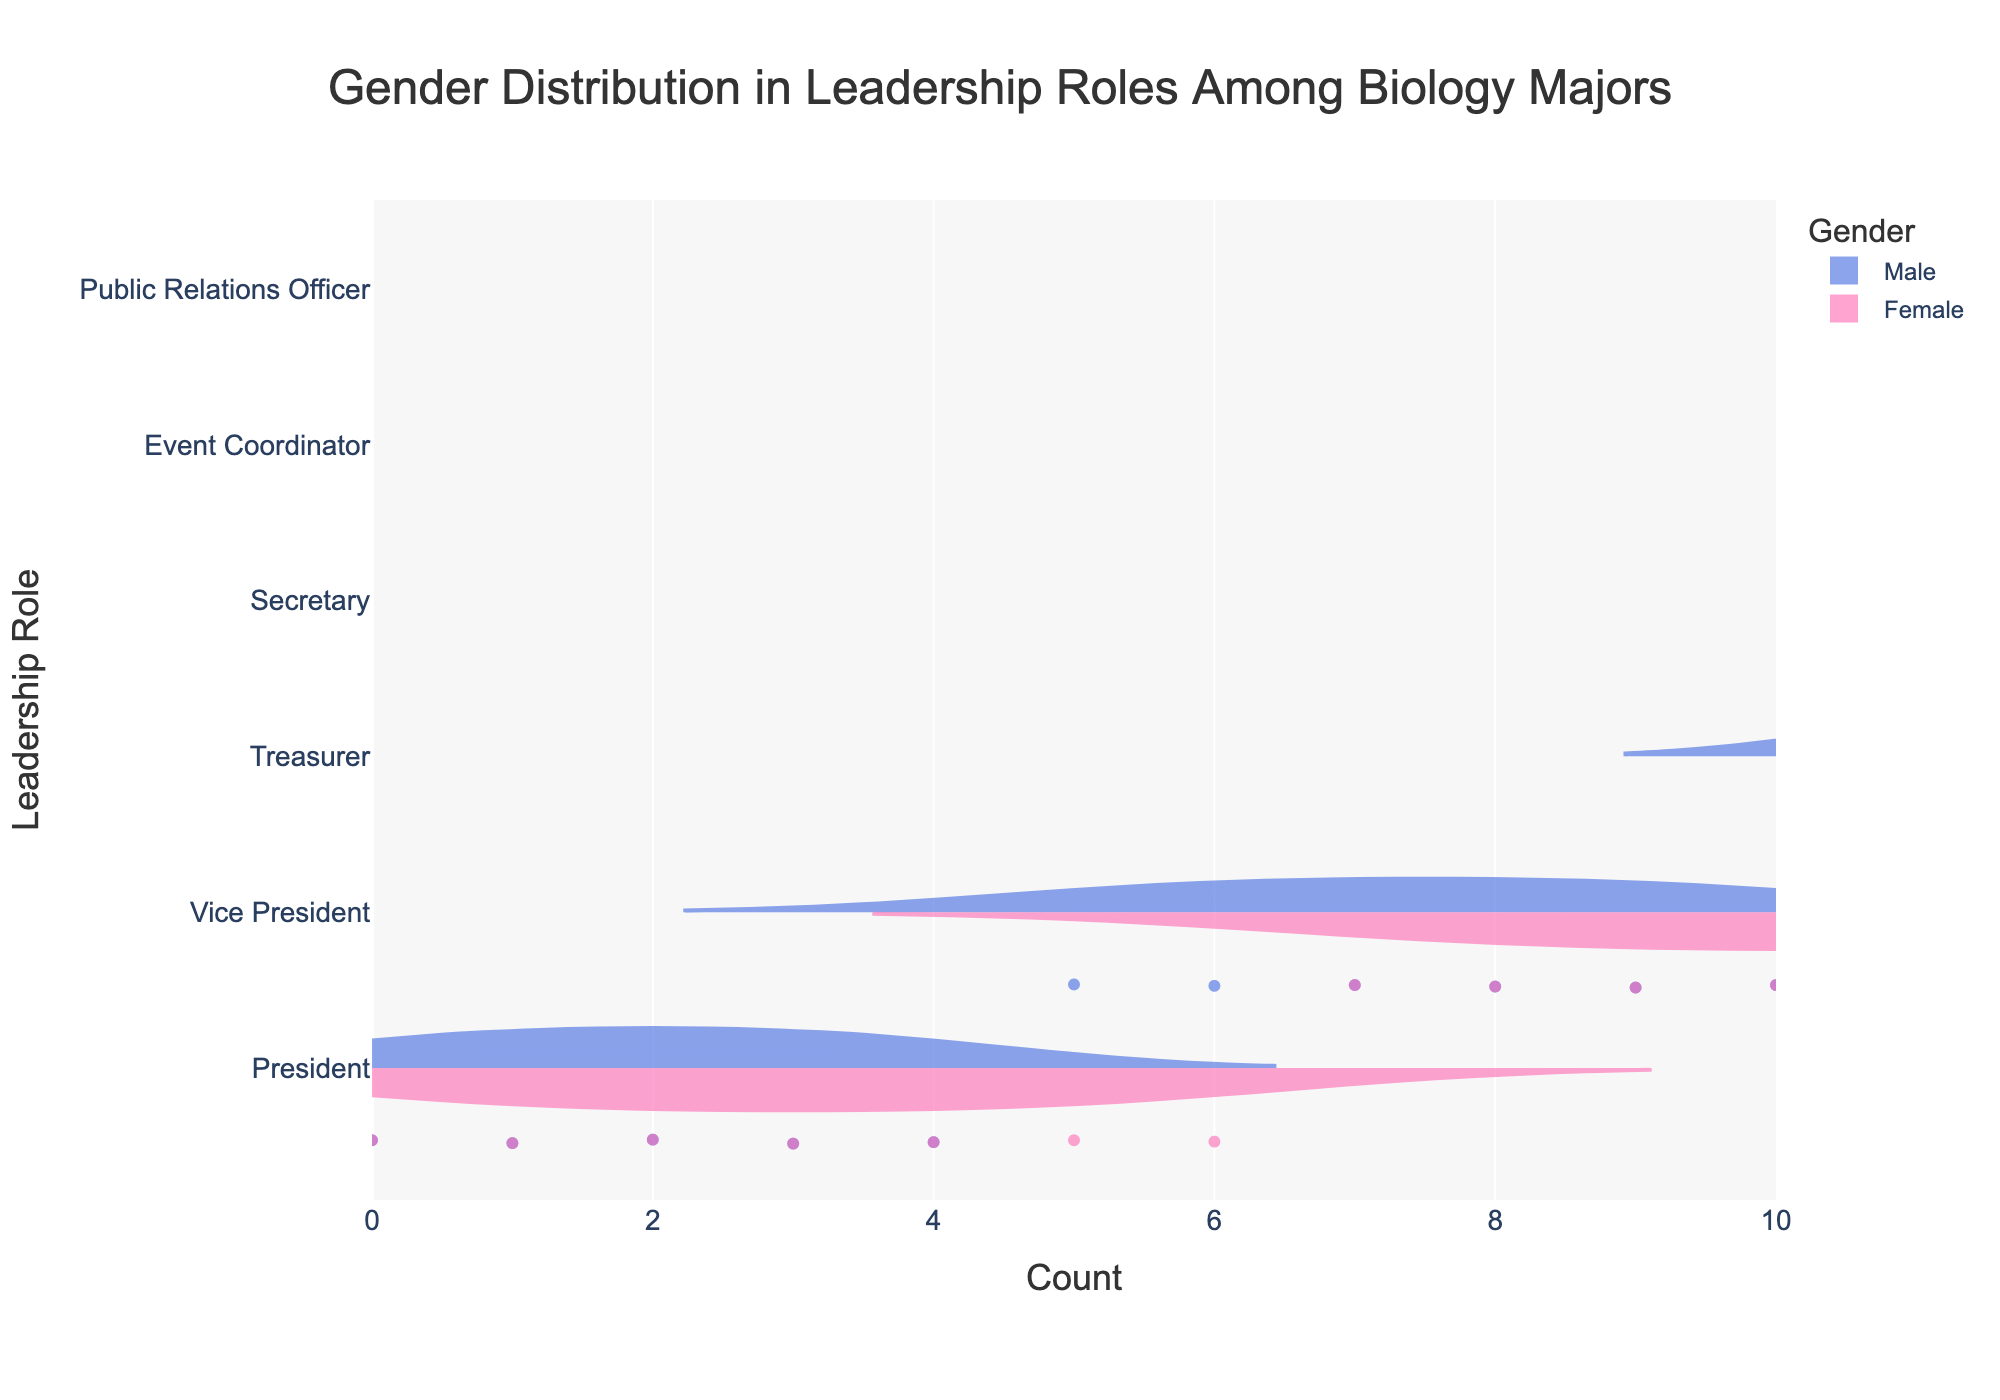What's the title of the figure? The title of the figure is located at the top and is generally larger and more prominent compared to other text elements in the plot.
Answer: Gender Distribution in Leadership Roles Among Biology Majors Which gender has more Presidents according to the figure? Look for the 'President' category on the y-axis and compare the width or density of the two violins for 'Male' and 'Female'.
Answer: Female What is the total number of Secretaries in the figure? Identify the count of Secretaries for both Males and Females by looking at the density of points in the 'Secretary' category on the y-axis, then sum those counts.
Answer: 13 Which role has the smallest difference in count between males and females? For all roles, calculate the absolute difference in counts between males and females by examining the lengths or densities of the violins associated with each role, then identify the smallest difference.
Answer: Public Relations Officer Comparing Treasurers, do males or females have a higher count? Locate the 'Treasurer' category on the y-axis and compare the width, density, or area of the corresponding violins for 'Male' and 'Female'.
Answer: Female What is the average number of people for the role of Vice President across both genders? Find the counts for both Males and Females in the 'Vice President' category, sum these numbers, and divide by 2.
Answer: 7 Which role has the most balanced gender distribution by count? Examine the violins for each role to see where the 'Male' and 'Female' distributions appear most similar in length, density, or area.
Answer: Public Relations Officer How many roles have females in higher counts than males? Count the roles where the 'Female' violins extend further or have a higher density compared to the 'Male' violins.
Answer: 4 What is the total count of individuals in the President and Secretary roles combined? Sum the counts of both genders in the President and Secretary roles by looking at the lengths or densities of the violins.
Answer: 25 By looking at the distribution for Event Coordinators, is there a noticeable asymmetry in gender representation? Observe the lengths and densities of the violins in the 'Event Coordinator' category to determine if one gender's distribution noticeably extends beyond the other.
Answer: Yes 